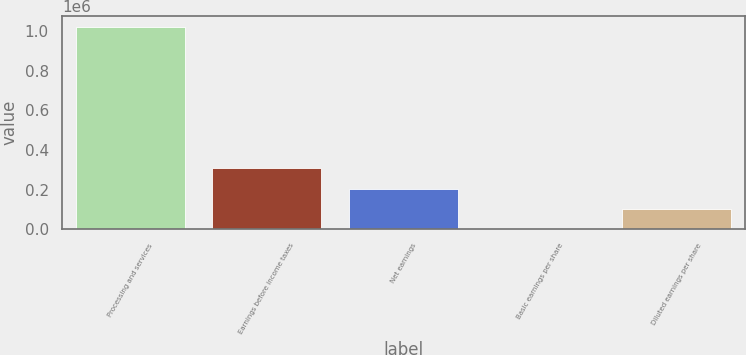<chart> <loc_0><loc_0><loc_500><loc_500><bar_chart><fcel>Processing and services<fcel>Earnings before income taxes<fcel>Net earnings<fcel>Basic earnings per share<fcel>Diluted earnings per share<nl><fcel>1.02195e+06<fcel>306584<fcel>204389<fcel>0.34<fcel>102195<nl></chart> 